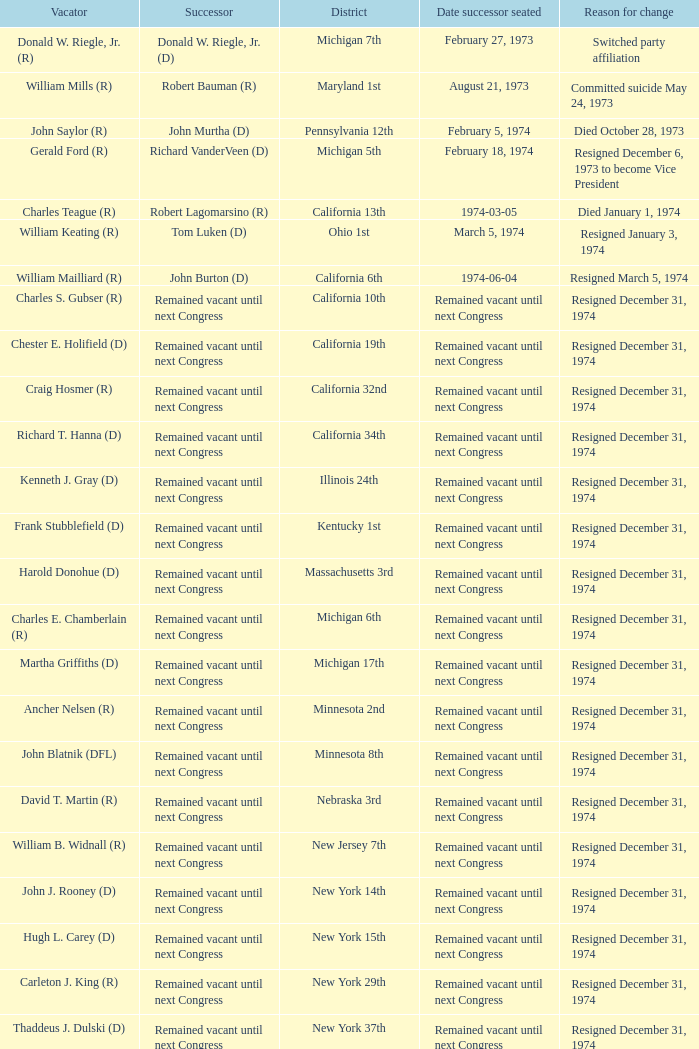When was the date successor seated when the vacator was charles e. chamberlain (r)? Remained vacant until next Congress. 